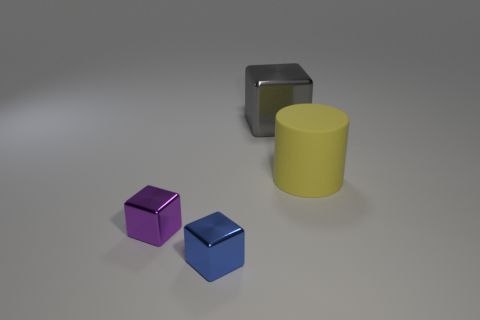What materials do the objects in the image seem to be made from? The objects display different color tones and reflection characteristics that suggest they are made of various materials. The yellow cylinder and the purple cube have a matte appearance, likely indicating a plastic or painted surface. The blue cube has a slightly reflective surface, which might be indicative of a metallic paint or a different type of polish. The silver-gray object in the back, which has a more pronounced reflection, could be made of metal. 